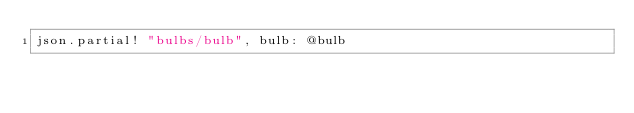Convert code to text. <code><loc_0><loc_0><loc_500><loc_500><_Ruby_>json.partial! "bulbs/bulb", bulb: @bulb
</code> 